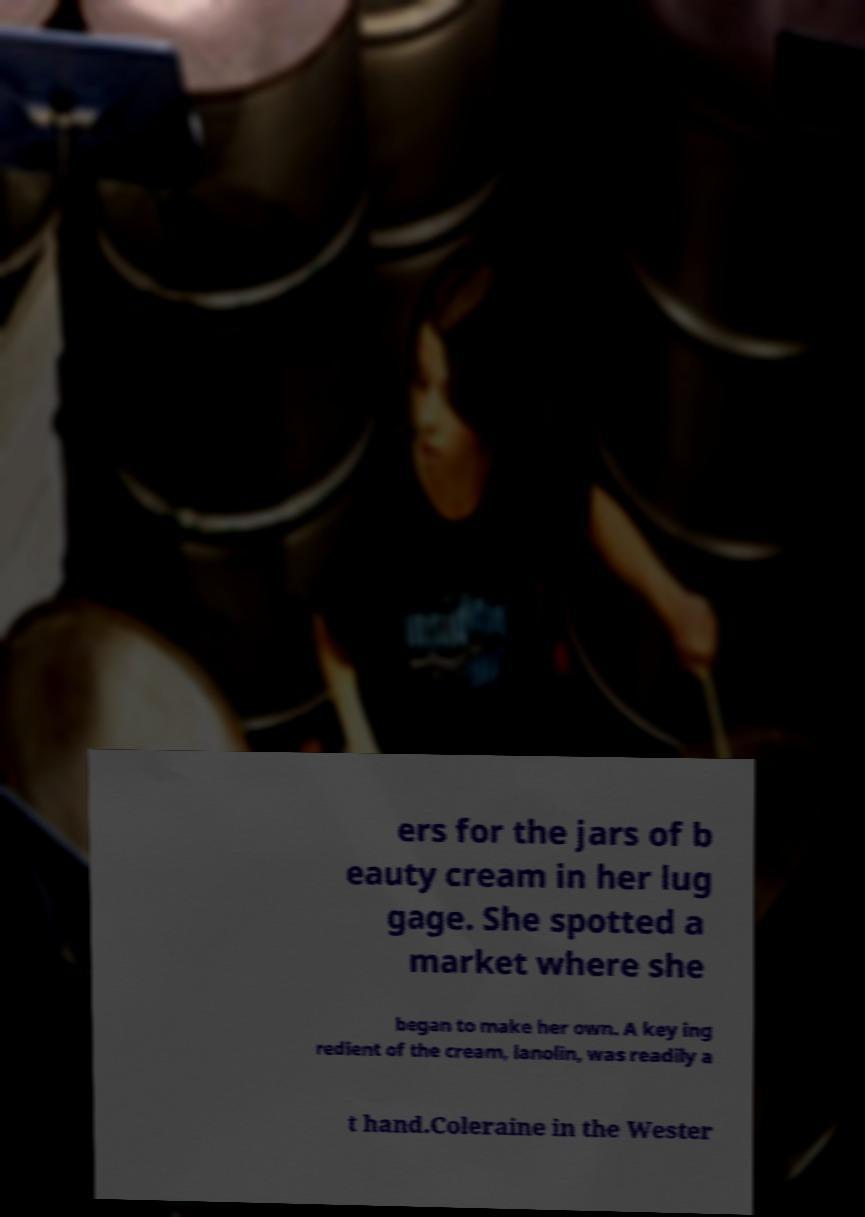Please identify and transcribe the text found in this image. ers for the jars of b eauty cream in her lug gage. She spotted a market where she began to make her own. A key ing redient of the cream, lanolin, was readily a t hand.Coleraine in the Wester 